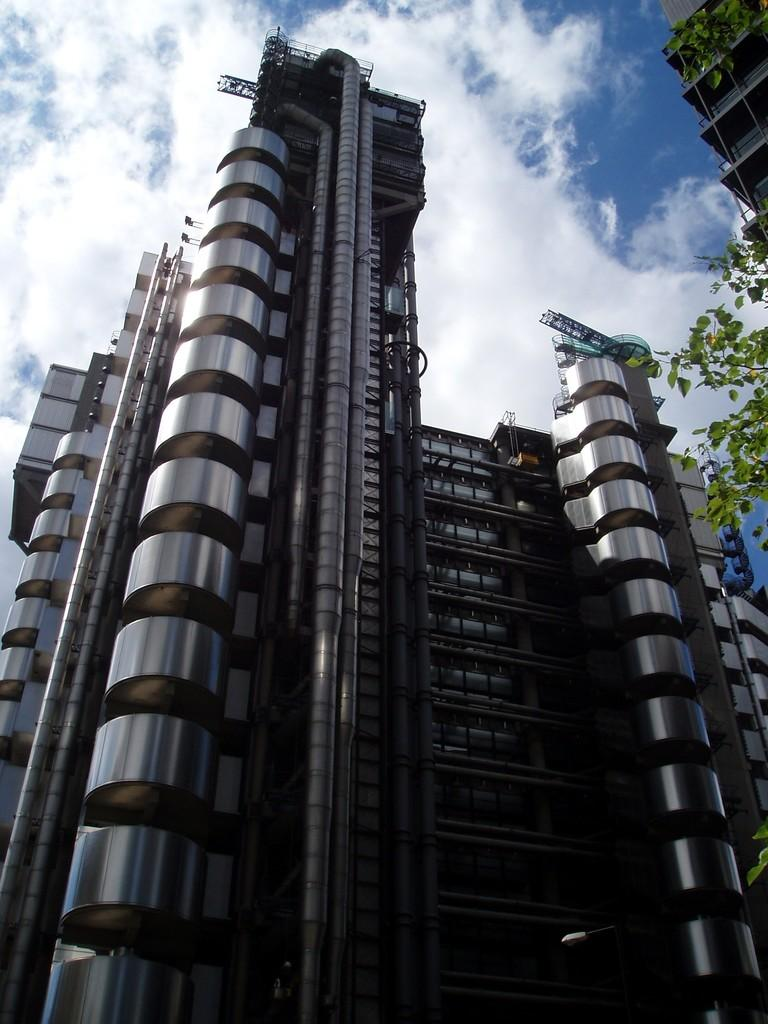What type of structures can be seen in the image? There are buildings in the image. What other natural elements are present in the image? There are trees in the image. What is visible at the top of the image? The sky is visible at the top of the image. What type of cake is being served at the event in the image? There is no event or cake present in the image; it features buildings, trees, and the sky. 